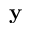<formula> <loc_0><loc_0><loc_500><loc_500>y</formula> 